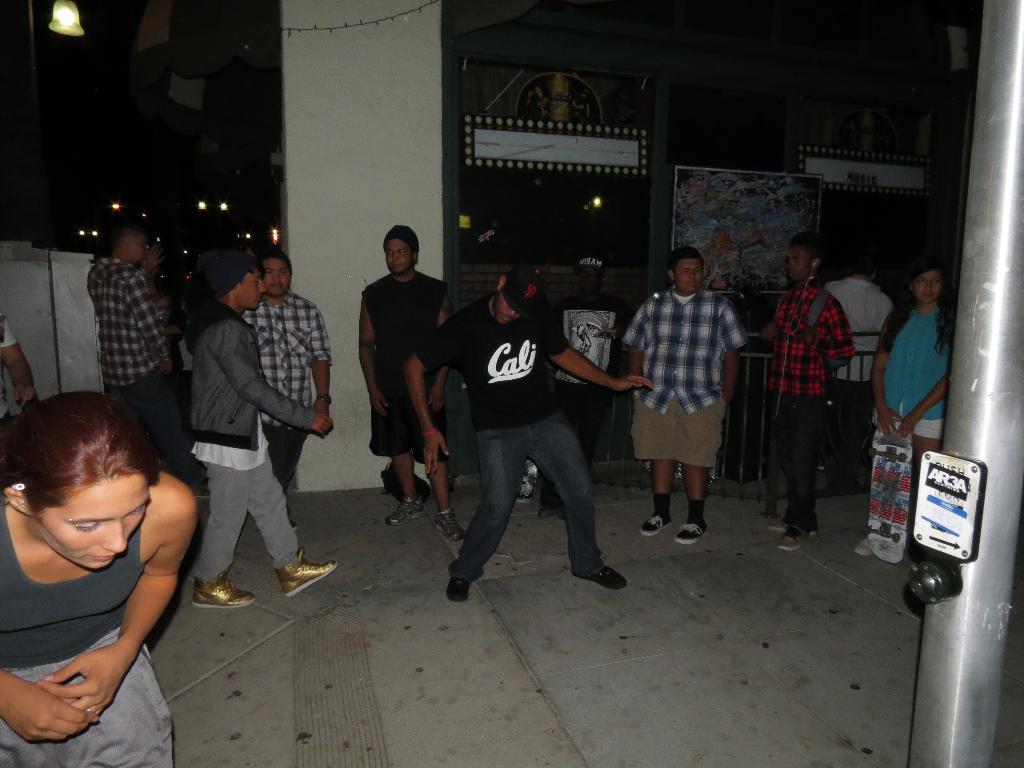Describe this image in one or two sentences. This picture shows few people standing and we see a man walking and other man dancing and we see a woman holding a skateboard in her hand and we see a pole and a frame on the wall. 